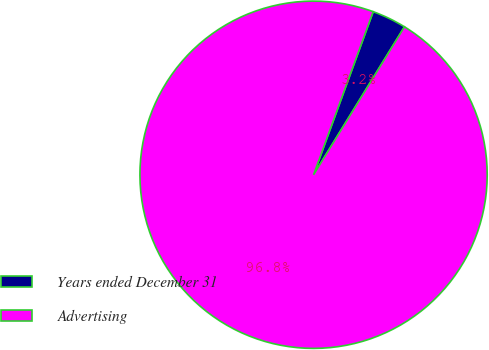Convert chart to OTSL. <chart><loc_0><loc_0><loc_500><loc_500><pie_chart><fcel>Years ended December 31<fcel>Advertising<nl><fcel>3.19%<fcel>96.81%<nl></chart> 